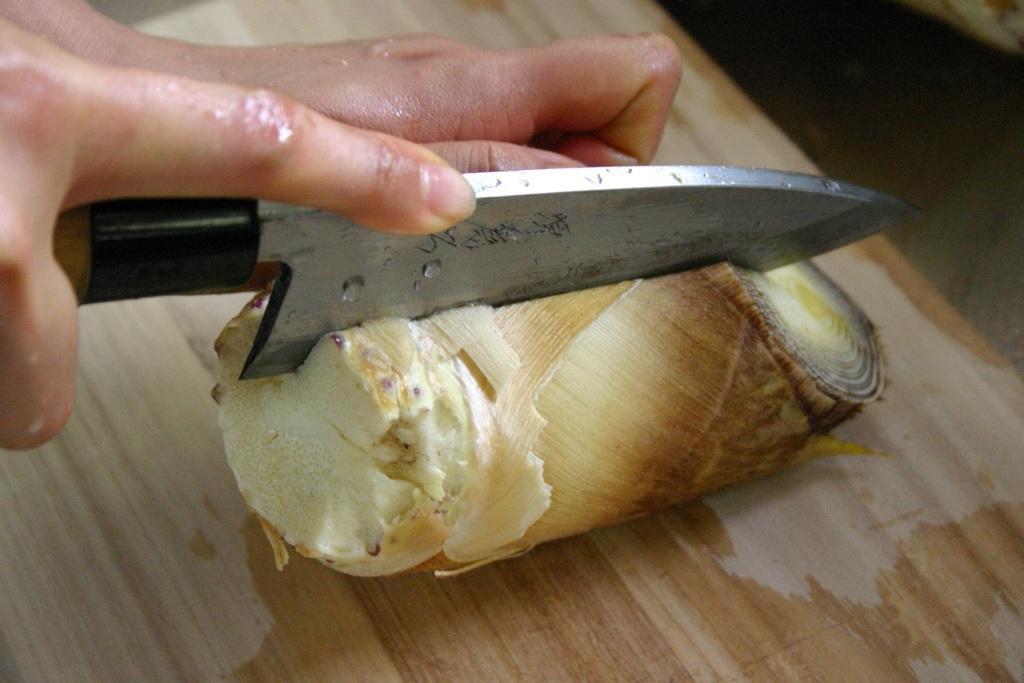How would you summarize this image in a sentence or two? In this image, we can see human hands is holding a knife and cutting an object on the chopping board. Here we can see a surface. 